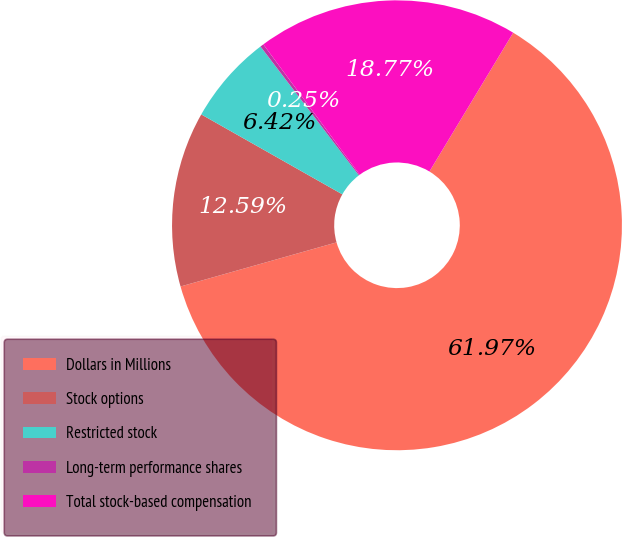<chart> <loc_0><loc_0><loc_500><loc_500><pie_chart><fcel>Dollars in Millions<fcel>Stock options<fcel>Restricted stock<fcel>Long-term performance shares<fcel>Total stock-based compensation<nl><fcel>61.98%<fcel>12.59%<fcel>6.42%<fcel>0.25%<fcel>18.77%<nl></chart> 